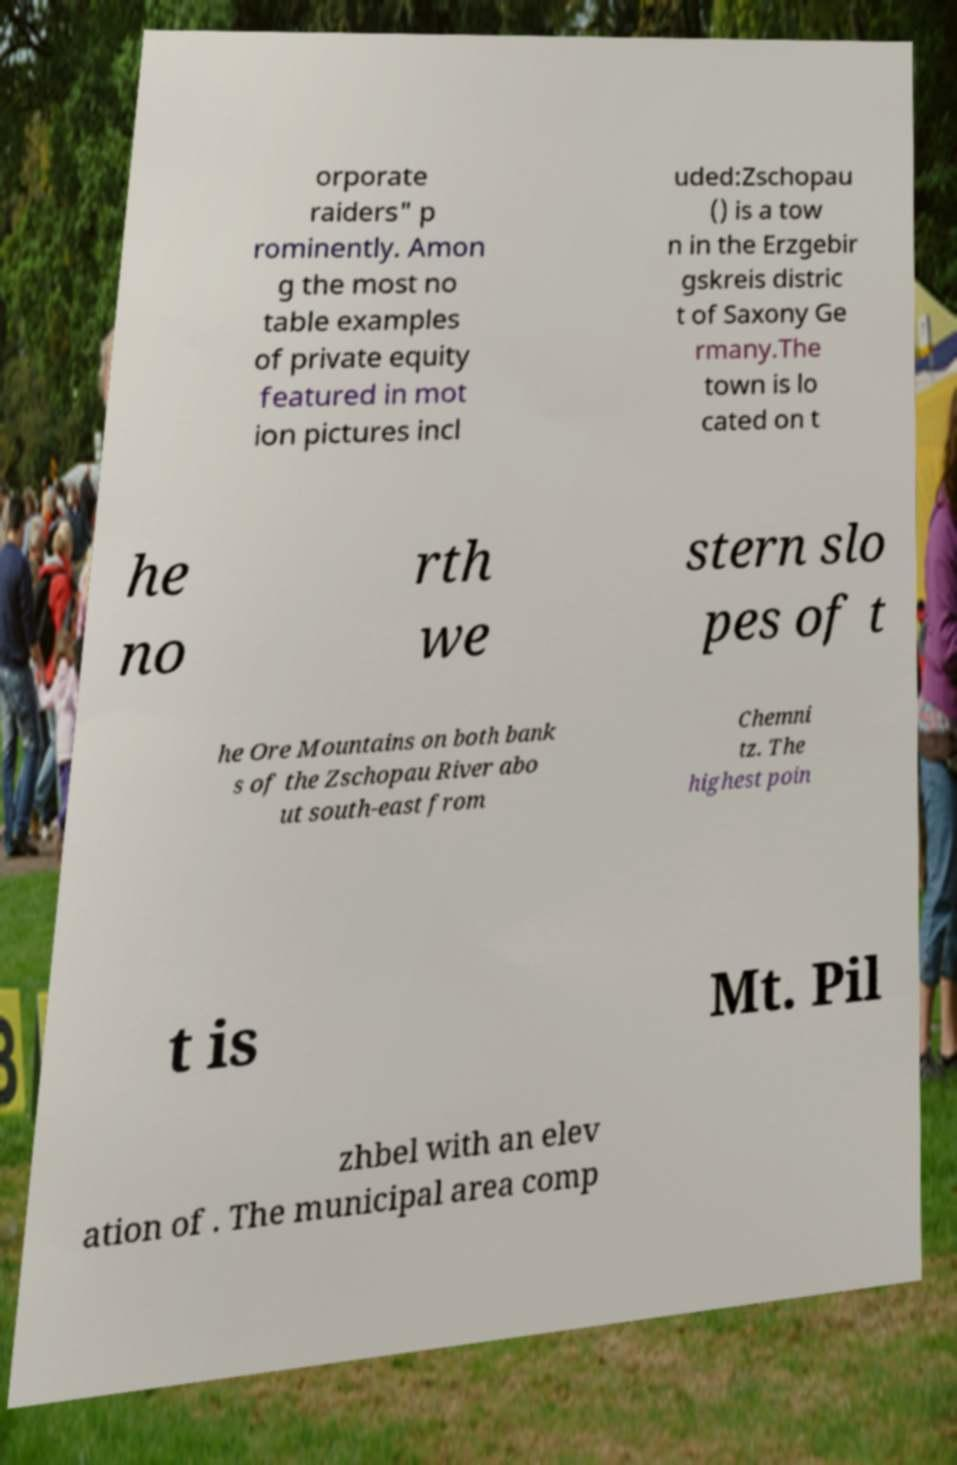Can you read and provide the text displayed in the image?This photo seems to have some interesting text. Can you extract and type it out for me? orporate raiders" p rominently. Amon g the most no table examples of private equity featured in mot ion pictures incl uded:Zschopau () is a tow n in the Erzgebir gskreis distric t of Saxony Ge rmany.The town is lo cated on t he no rth we stern slo pes of t he Ore Mountains on both bank s of the Zschopau River abo ut south-east from Chemni tz. The highest poin t is Mt. Pil zhbel with an elev ation of . The municipal area comp 